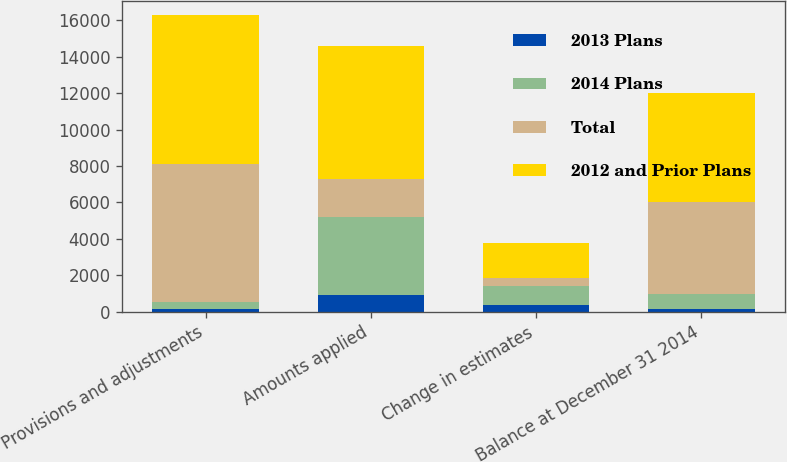Convert chart to OTSL. <chart><loc_0><loc_0><loc_500><loc_500><stacked_bar_chart><ecel><fcel>Provisions and adjustments<fcel>Amounts applied<fcel>Change in estimates<fcel>Balance at December 31 2014<nl><fcel>2013 Plans<fcel>178<fcel>900<fcel>387<fcel>173<nl><fcel>2014 Plans<fcel>352<fcel>4309<fcel>1029<fcel>778<nl><fcel>Total<fcel>7603<fcel>2080<fcel>461<fcel>5062<nl><fcel>2012 and Prior Plans<fcel>8133<fcel>7289<fcel>1877<fcel>6013<nl></chart> 